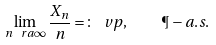Convert formula to latex. <formula><loc_0><loc_0><loc_500><loc_500>\lim _ { n \ r a \infty } \frac { X _ { n } } { n } = \colon \ v p , \quad \P - a . s .</formula> 